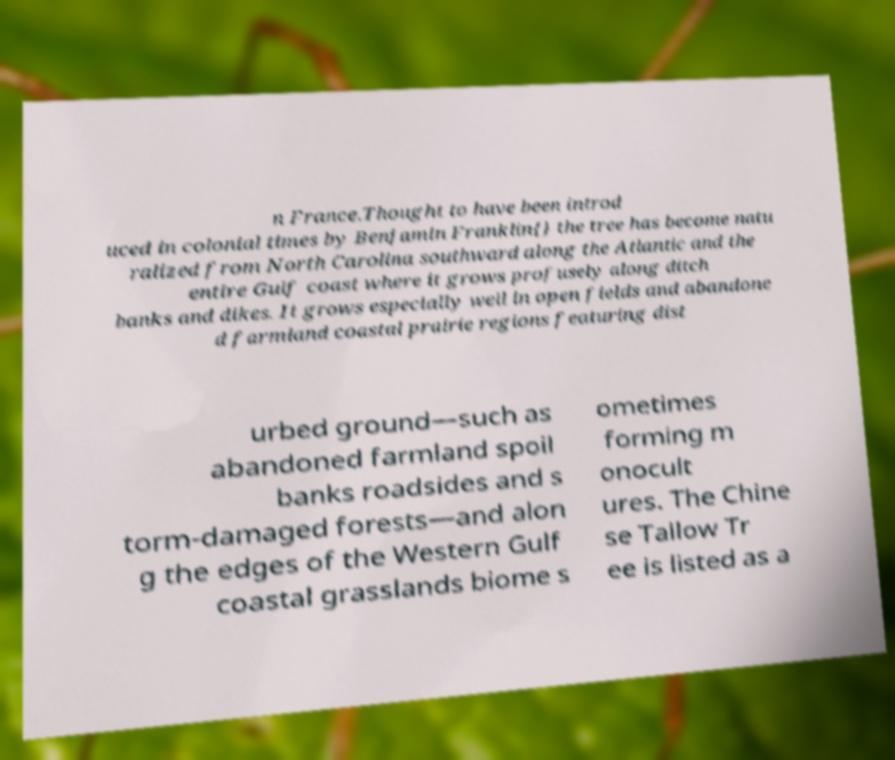Can you accurately transcribe the text from the provided image for me? n France.Thought to have been introd uced in colonial times by Benjamin Franklin{} the tree has become natu ralized from North Carolina southward along the Atlantic and the entire Gulf coast where it grows profusely along ditch banks and dikes. It grows especially well in open fields and abandone d farmland coastal prairie regions featuring dist urbed ground—such as abandoned farmland spoil banks roadsides and s torm-damaged forests—and alon g the edges of the Western Gulf coastal grasslands biome s ometimes forming m onocult ures. The Chine se Tallow Tr ee is listed as a 